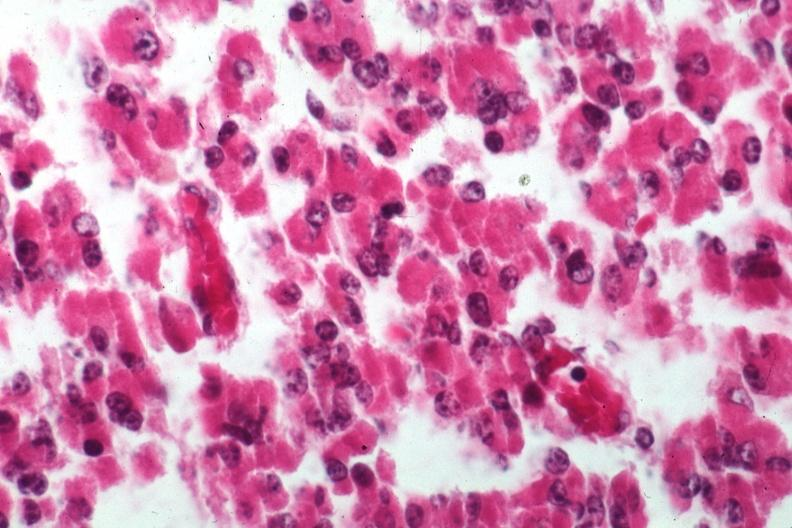does abdomen show cells of adenoma?
Answer the question using a single word or phrase. No 